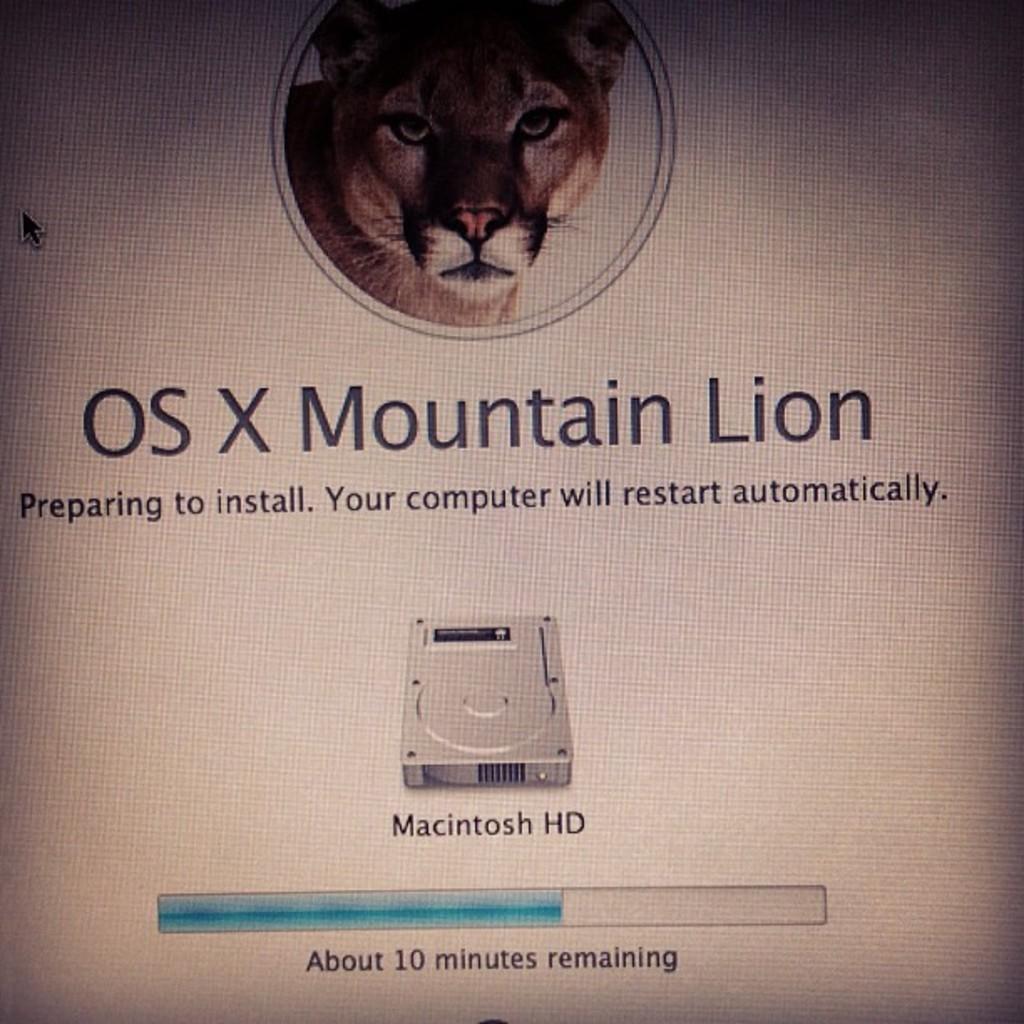In one or two sentences, can you explain what this image depicts? In this picture, we can see a monitor, on that screen, we can see a lion and some text on the monitor screen. 